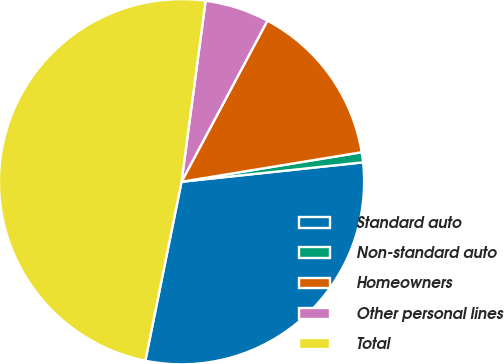Convert chart to OTSL. <chart><loc_0><loc_0><loc_500><loc_500><pie_chart><fcel>Standard auto<fcel>Non-standard auto<fcel>Homeowners<fcel>Other personal lines<fcel>Total<nl><fcel>29.87%<fcel>0.89%<fcel>14.62%<fcel>5.69%<fcel>48.93%<nl></chart> 